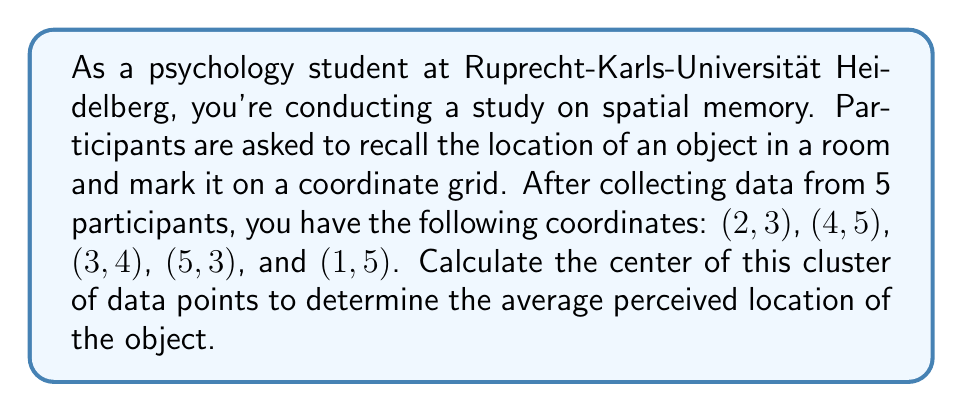Can you solve this math problem? To find the center of a cluster of data points in a coordinate plane, we need to calculate the average (mean) of the x-coordinates and y-coordinates separately. This point is also known as the centroid.

Step 1: Separate the x and y coordinates:
x-coordinates: 2, 4, 3, 5, 1
y-coordinates: 3, 5, 4, 3, 5

Step 2: Calculate the average of x-coordinates:
$$ \bar{x} = \frac{\sum_{i=1}^{n} x_i}{n} = \frac{2 + 4 + 3 + 5 + 1}{5} = \frac{15}{5} = 3 $$

Step 3: Calculate the average of y-coordinates:
$$ \bar{y} = \frac{\sum_{i=1}^{n} y_i}{n} = \frac{3 + 5 + 4 + 3 + 5}{5} = \frac{20}{5} = 4 $$

Step 4: The center of the cluster is the point $(\bar{x}, \bar{y})$, which in this case is (3, 4).

[asy]
unitsize(1cm);
defaultpen(fontsize(10pt));

for(int i=-1; i<=6; ++i) {
  draw((i,-1)--(i,6),gray+0.5);
  draw((-1,i)--(6,i),gray+0.5);
}

dot((2,3),red);
dot((4,5),red);
dot((3,4),red);
dot((5,3),red);
dot((1,5),red);
dot((3,4),blue+3);

label("(2,3)",(2,3),SE);
label("(4,5)",(4,5),NE);
label("(3,4)",(3,4),NW);
label("(5,3)",(5,3),SE);
label("(1,5)",(1,5),NW);
label("(3,4)",(3,4),SW);

xaxis(xmin=-1, xmax=6, arrow=Arrow);
yaxis(ymin=-1, ymax=6, arrow=Arrow);

label("x",((6,0)),E);
label("y",(0,6),N);
[/asy]
Answer: The center of the cluster of data points is (3, 4). 